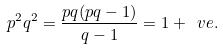<formula> <loc_0><loc_0><loc_500><loc_500>p ^ { 2 } q ^ { 2 } = \frac { p q ( p q - 1 ) } { q - 1 } = 1 + \ v e .</formula> 